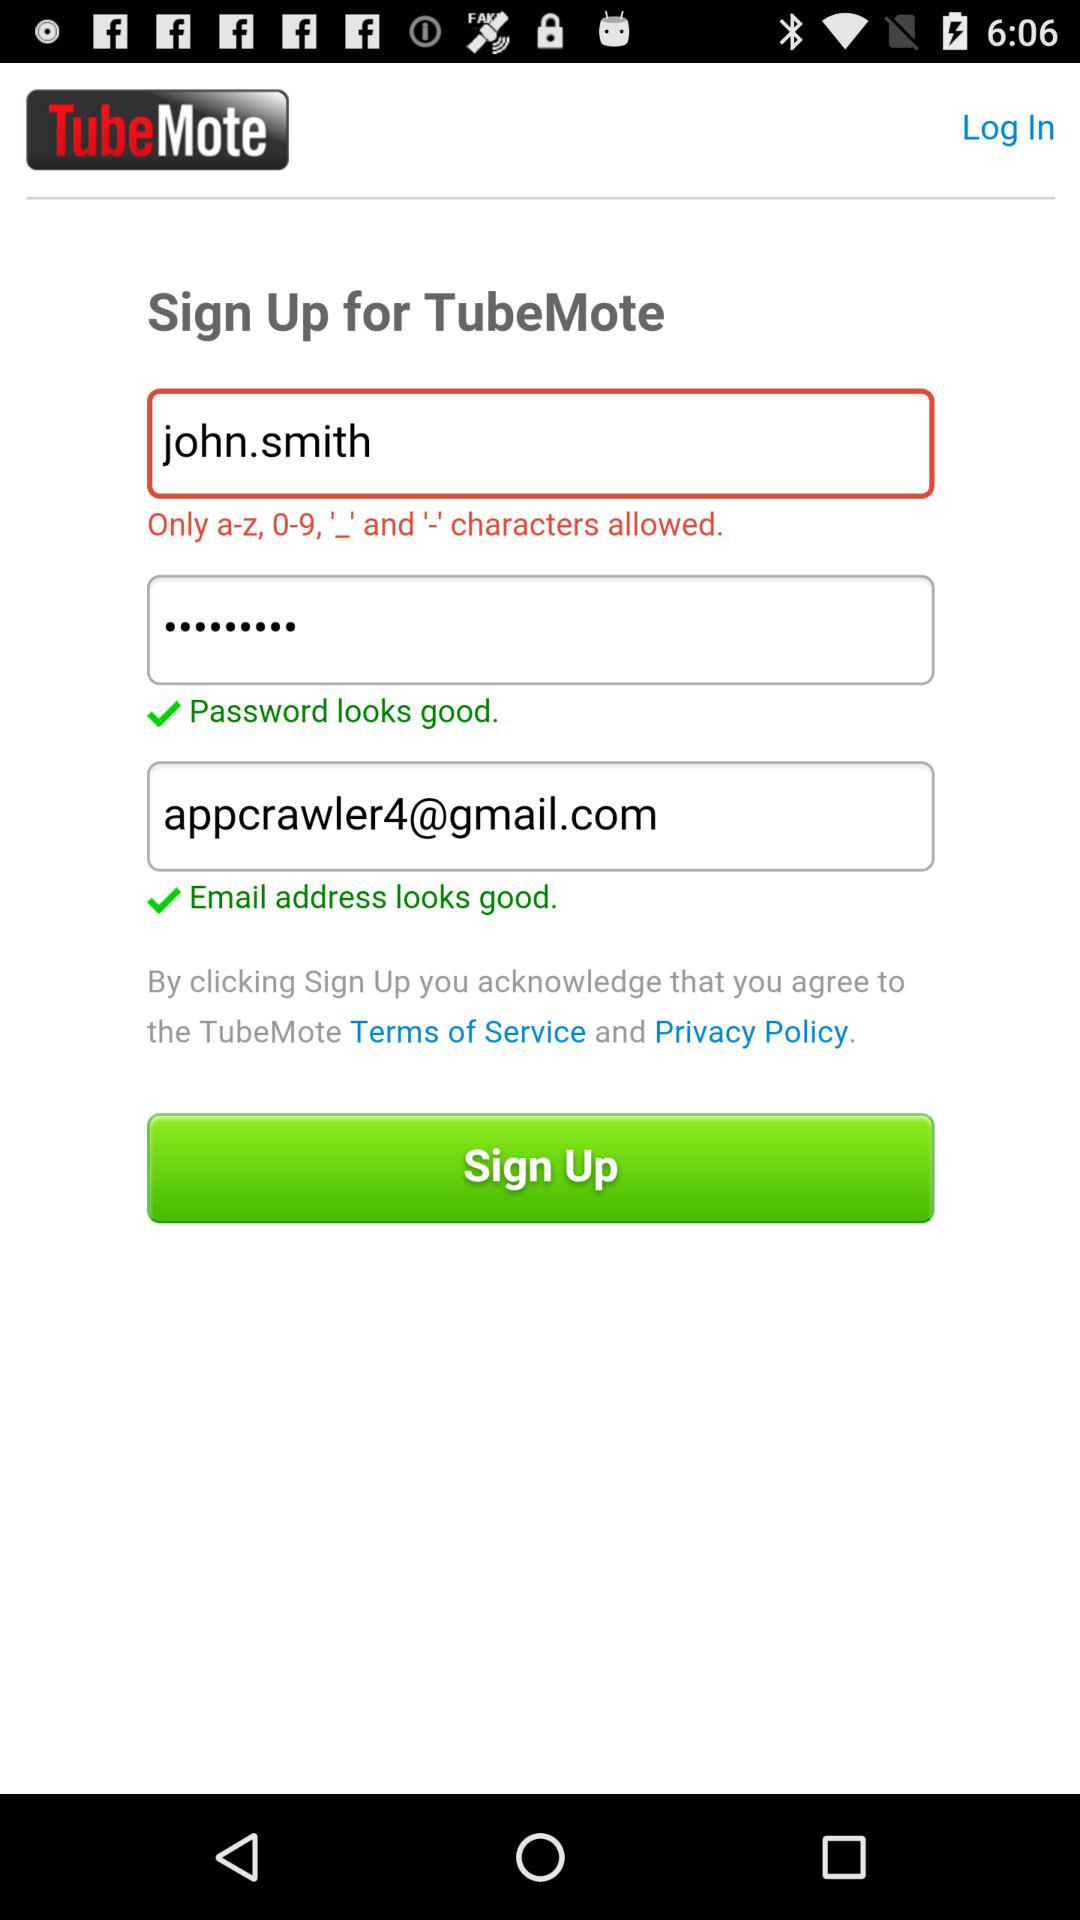What is an email address? The email address is appcrawler6@gmail.com. 